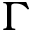<formula> <loc_0><loc_0><loc_500><loc_500>\Gamma</formula> 